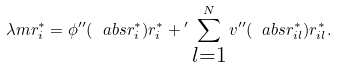<formula> <loc_0><loc_0><loc_500><loc_500>\lambda m { r } _ { i } ^ { * } = \phi ^ { \prime \prime } ( \ a b s { { r } _ { i } ^ { * } } ) { r } _ { i } ^ { * } + { ^ { \prime } } \sum _ { \substack { l = 1 } } ^ { N } v ^ { \prime \prime } ( \ a b s { { r } _ { i l } ^ { * } } ) { r } _ { i l } ^ { * } .</formula> 